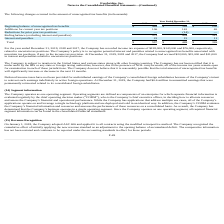From Everbridge's financial document, What was the income tax expense in 2019,2018 and 2017 respectively? The document contains multiple relevant values: $128,000, $143,000, $76,000. From the document: "orded income tax expense of $128,000, $143,000 and $76,000, respectively, related to uncertain tax positions. The Company’s policy is to recognize pot..." Also, What was the accrued interest and penalties in 2019, 2018 and 2017 respectively? The document contains multiple relevant values: $22,000, $15,000, $11,000. From the document: "9, 2018 and 2017, the Company had accrued $22,000, $15,000 and $11,000 in interest and penalties related to uncertain tax positions. The Company is su..." Also, What was the company's unremitted earnings in 2019? According to the financial document, $0.6 million. The relevant text states: "operations. At December 31, 2019, the Company had $0.6 million in unremitted earnings that were permanently reinvested related to its consolidated foreign subsidia..." Also, can you calculate: What was the change in the Additions for current year tax positions from 2018 to 2019? Based on the calculation: 106 - 142, the result is -36 (in thousands). This is based on the information: "Additions for current year tax positions 106 142 65 Additions for current year tax positions 106 142 65..." The key data points involved are: 106, 142. Additionally, In which year was Interest and penalties less than 20 thousand? The document shows two values: 2018 and 2017. Locate and analyze interest and penalties in row 8. From the document: "2019 2018 2017 2019 2018 2017..." Also, can you calculate: What was the average Reductions for prior year tax positions from 2017-2019? To answer this question, I need to perform calculations using the financial data. The calculation is: -(0 + 14 + 0) / 3, which equals -4.67 (in thousands). This is based on the information: "Additions for current year tax positions 106 142 65 Additions for current year tax positions 106 142 65..." The key data points involved are: 0, 14. 